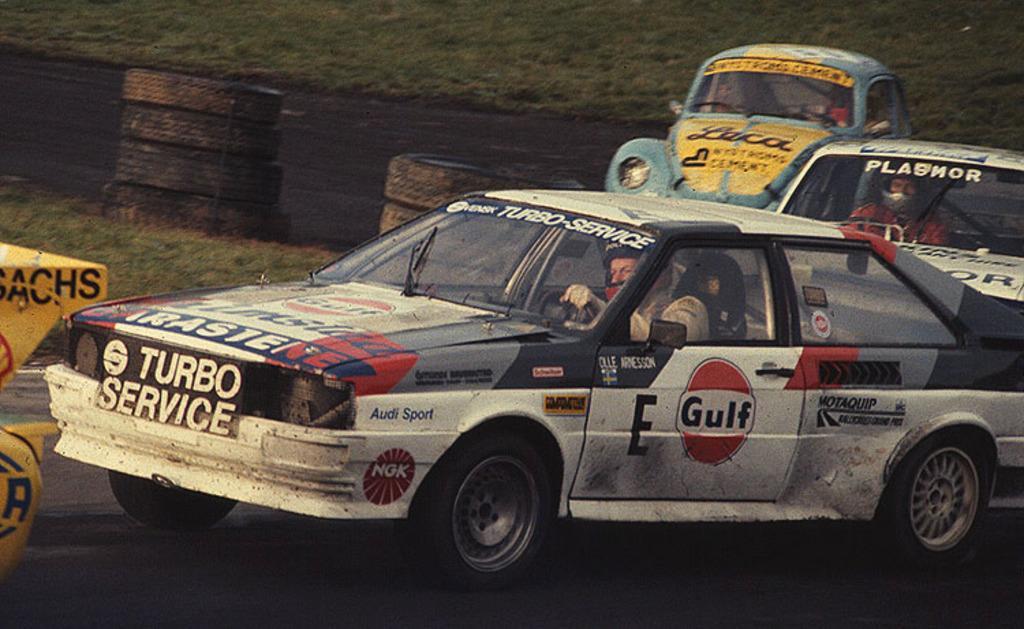Describe this image in one or two sentences. This picture shows couple of cars on the road and we see a car on the side and few tires on the side and we see grass on the ground. 